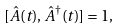<formula> <loc_0><loc_0><loc_500><loc_500>[ \hat { A } ( t ) , \hat { A } ^ { \dagger } ( t ) ] = 1 ,</formula> 